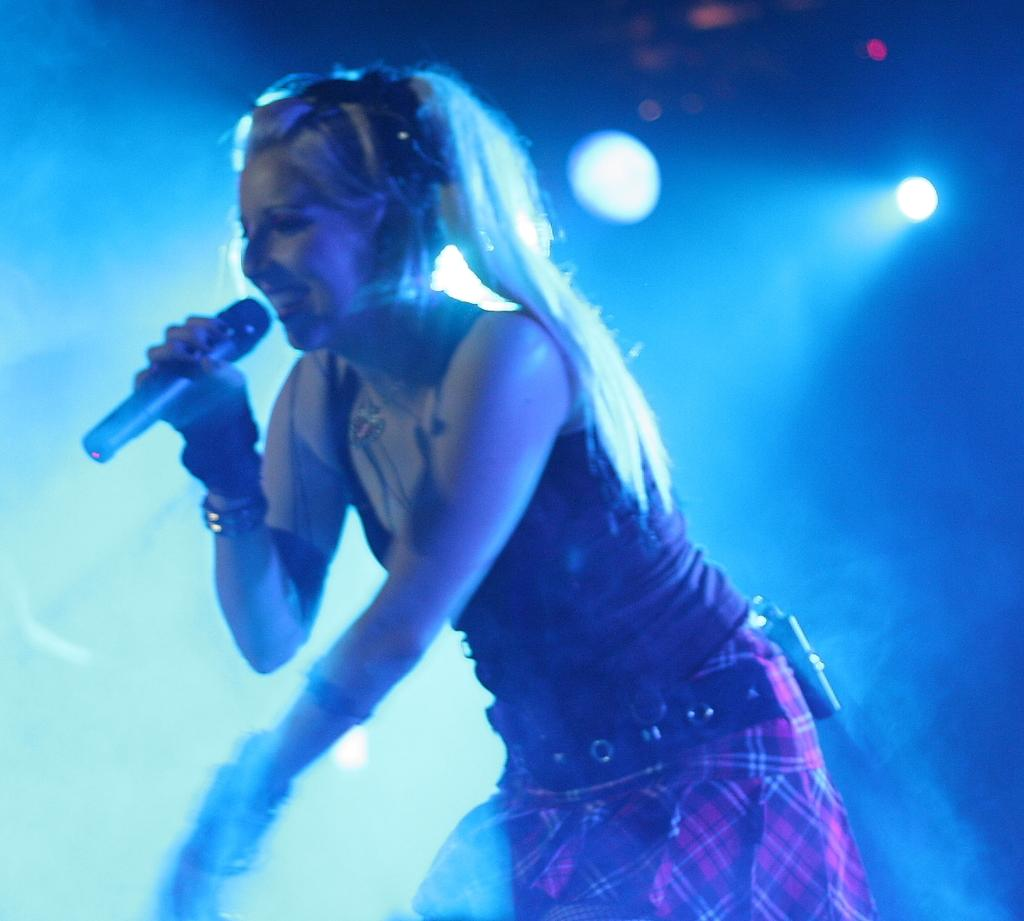What is the main subject of the image? There is a person in the image. What is the person holding in the image? The person is holding a microphone. What can be seen in the background of the image? There are lights visible in the background. How would you describe the overall lighting in the image? The background of the image is dark. What type of letter is the person holding in the image? There is no letter present in the image; the person is holding a microphone. Can you see any boots in the image? There are no boots visible in the image. Is the person using a toothbrush in the image? There is no toothbrush present in the image. 